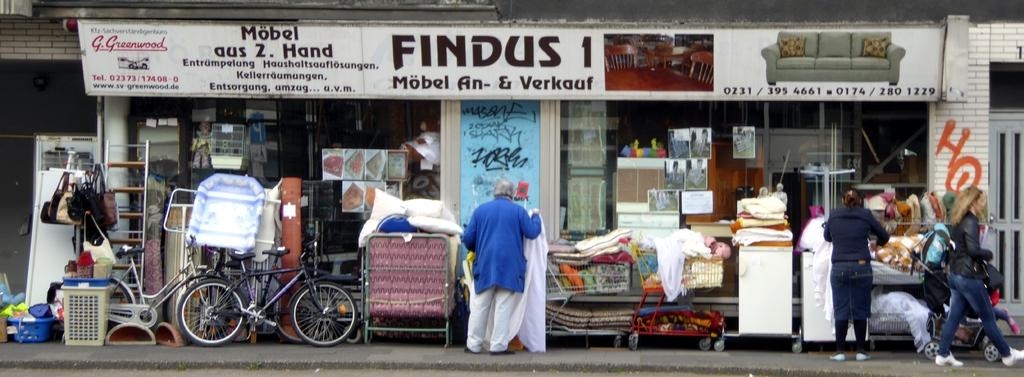<image>
Share a concise interpretation of the image provided. A white sign says "FINDUS" above a shop. 